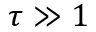Convert formula to latex. <formula><loc_0><loc_0><loc_500><loc_500>\tau \gg 1</formula> 